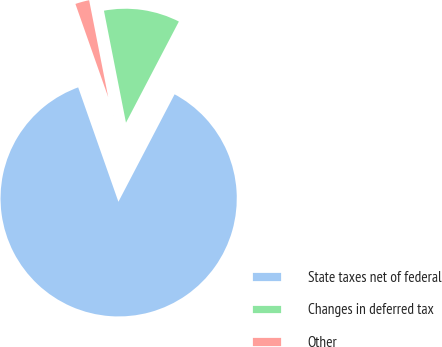<chart> <loc_0><loc_0><loc_500><loc_500><pie_chart><fcel>State taxes net of federal<fcel>Changes in deferred tax<fcel>Other<nl><fcel>86.96%<fcel>10.76%<fcel>2.29%<nl></chart> 